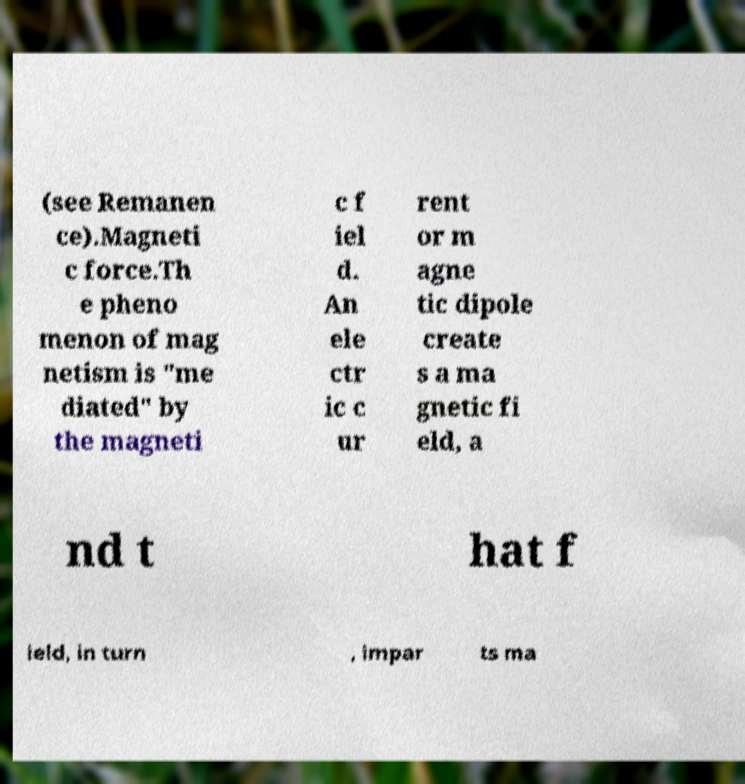Please read and relay the text visible in this image. What does it say? (see Remanen ce).Magneti c force.Th e pheno menon of mag netism is "me diated" by the magneti c f iel d. An ele ctr ic c ur rent or m agne tic dipole create s a ma gnetic fi eld, a nd t hat f ield, in turn , impar ts ma 